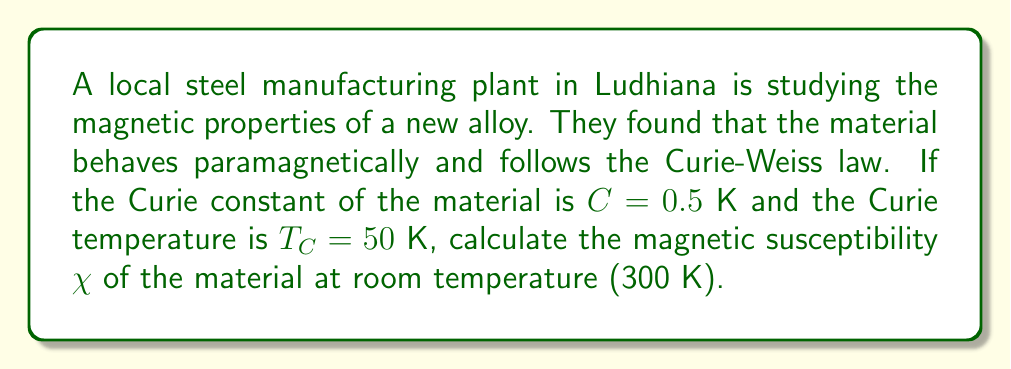Can you answer this question? To solve this problem, we'll use the Curie-Weiss model for paramagnetic materials. The steps are as follows:

1) The Curie-Weiss law for magnetic susceptibility is given by:

   $$\chi = \frac{C}{T - T_C}$$

   where $\chi$ is the magnetic susceptibility, $C$ is the Curie constant, $T$ is the temperature, and $T_C$ is the Curie temperature.

2) We are given:
   - Curie constant, $C = 0.5$ K
   - Curie temperature, $T_C = 50$ K
   - Room temperature, $T = 300$ K

3) Let's substitute these values into the equation:

   $$\chi = \frac{0.5 \text{ K}}{300 \text{ K} - 50 \text{ K}}$$

4) Simplify:
   $$\chi = \frac{0.5}{250} = 0.002$$

5) The magnetic susceptibility is a dimensionless quantity, so our final answer is 0.002.
Answer: 0.002 